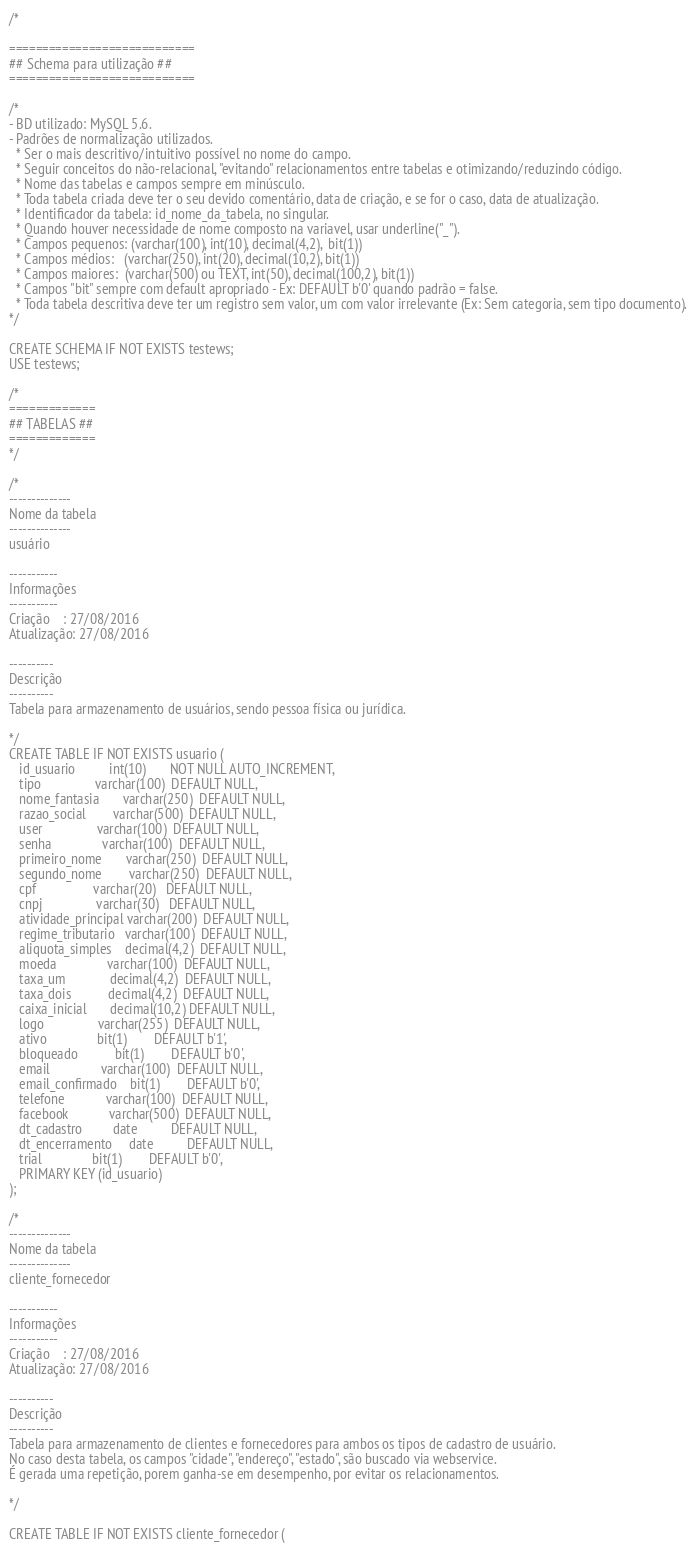Convert code to text. <code><loc_0><loc_0><loc_500><loc_500><_SQL_>/*

============================
## Schema para utilização ##
============================

/*
- BD utilizado: MySQL 5.6.
- Padrões de normalização utilizados.
  * Ser o mais descritivo/intuitivo possível no nome do campo.
  * Seguir conceitos do não-relacional, "evitando" relacionamentos entre tabelas e otimizando/reduzindo código.
  * Nome das tabelas e campos sempre em minúsculo.
  * Toda tabela criada deve ter o seu devido comentário, data de criação, e se for o caso, data de atualização.
  * Identificador da tabela: id_nome_da_tabela, no singular.
  * Quando houver necessidade de nome composto na variavel, usar underline("_").
  * Campos pequenos: (varchar(100), int(10), decimal(4,2),  bit(1))
  * Campos médios:   (varchar(250), int(20), decimal(10,2), bit(1))
  * Campos maiores:  (varchar(500) ou TEXT, int(50), decimal(100,2), bit(1))
  * Campos "bit" sempre com default apropriado - Ex: DEFAULT b'0' quando padrão = false.
  * Toda tabela descritiva deve ter um registro sem valor, um com valor irrelevante (Ex: Sem categoria, sem tipo documento).
*/

CREATE SCHEMA IF NOT EXISTS testews;
USE testews;

/*
=============
## TABELAS ##
=============
*/

/*
--------------
Nome da tabela
--------------
usuário

-----------
Informações
-----------
Criação    : 27/08/2016
Atualização: 27/08/2016

----------
Descrição
----------
Tabela para armazenamento de usuários, sendo pessoa física ou jurídica.

*/
CREATE TABLE IF NOT EXISTS usuario (
   id_usuario          int(10)       NOT NULL AUTO_INCREMENT,
   tipo                varchar(100)  DEFAULT NULL,
   nome_fantasia       varchar(250)  DEFAULT NULL,
   razao_social        varchar(500)  DEFAULT NULL,
   user                varchar(100)  DEFAULT NULL,
   senha               varchar(100)  DEFAULT NULL,
   primeiro_nome       varchar(250)  DEFAULT NULL,
   segundo_nome        varchar(250)  DEFAULT NULL,
   cpf                 varchar(20)   DEFAULT NULL,
   cnpj                varchar(30)   DEFAULT NULL,
   atividade_principal varchar(200)  DEFAULT NULL,
   regime_tributario   varchar(100)  DEFAULT NULL,
   aliquota_simples    decimal(4,2)  DEFAULT NULL,
   moeda               varchar(100)  DEFAULT NULL,
   taxa_um             decimal(4,2)  DEFAULT NULL,
   taxa_dois           decimal(4,2)  DEFAULT NULL,
   caixa_inicial       decimal(10,2) DEFAULT NULL,
   logo                varchar(255)  DEFAULT NULL,
   ativo               bit(1)        DEFAULT b'1',
   bloqueado           bit(1)        DEFAULT b'0',
   email               varchar(100)  DEFAULT NULL,
   email_confirmado    bit(1)        DEFAULT b'0',
   telefone            varchar(100)  DEFAULT NULL,
   facebook            varchar(500)  DEFAULT NULL,
   dt_cadastro         date          DEFAULT NULL,
   dt_encerramento     date          DEFAULT NULL,
   trial               bit(1)        DEFAULT b'0',
   PRIMARY KEY (id_usuario)
);

/*
--------------
Nome da tabela
--------------
cliente_fornecedor

-----------
Informações
-----------
Criação    : 27/08/2016
Atualização: 27/08/2016

----------
Descrição
----------
Tabela para armazenamento de clientes e fornecedores para ambos os tipos de cadastro de usuário.
No caso desta tabela, os campos "cidade", "endereço", "estado", são buscado via webservice.
É gerada uma repetição, porem ganha-se em desempenho, por evitar os relacionamentos.

*/

CREATE TABLE IF NOT EXISTS cliente_fornecedor (</code> 